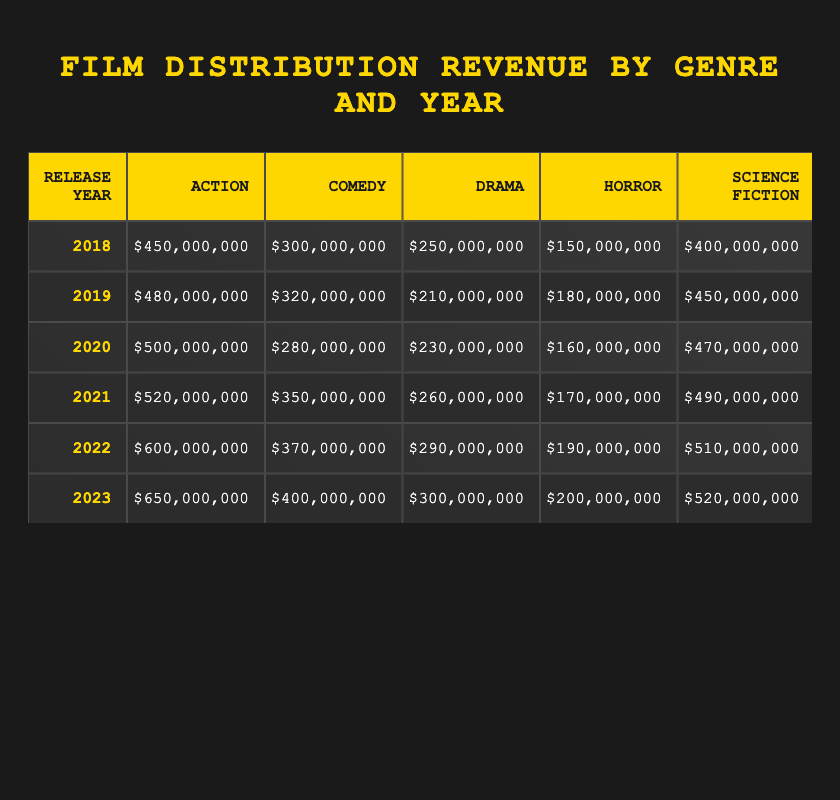What was the highest revenue for Action films, and in what year did it occur? The highest revenue for Action films is $650,000,000 in the year 2023, as this value is clearly indicated in the table.
Answer: 2023, $650,000,000 What is the average revenue for Animation films over the years 2018-2023? To find the average, add up the revenue for Animation films across the years: 200,000,000 + 220,000,000 + 210,000,000 + 240,000,000 + 250,000,000 + 270,000,000 = 1,480,000,000. Then divide by the number of years (6): 1,480,000,000 / 6 = 246,666,667.
Answer: 246,666,667 Did Horror films have a revenue higher than $200,000,000 in 2022? The revenue for Horror films in 2022 is $190,000,000, which is less than $200,000,000, so the statement is false.
Answer: No Which genre had the lowest total revenue in 2020? The total revenues for each genre in 2020 are: Action ($500,000,000), Comedy ($280,000,000), Drama ($230,000,000), Horror ($160,000,000), Science Fiction ($470,000,000), Animation ($210,000,000). The lowest is Horror at $160,000,000.
Answer: Horror What is the difference in revenue between the highest and lowest earning genres in 2021? The highest revenue in 2021 was for Action films at $520,000,000, and the lowest was for Horror films at $170,000,000. The difference is calculated as $520,000,000 - $170,000,000 = $350,000,000.
Answer: $350,000,000 In which year did Comedy films generate more than $350,000,000? According to the table, Comedy films generated over $350,000,000 in the years 2021 ($350,000,000), 2022 ($370,000,000), and 2023 ($400,000,000). The first year when the amount exceeded $350,000,000 is 2021, as it just matches in that year and exceeds in subsequent years.
Answer: 2021 What was the total revenue for Science Fiction films from 2018 to 2023? The revenues for Science Fiction films are: 400,000,000 (2018), 450,000,000 (2019), 470,000,000 (2020), 490,000,000 (2021), 510,000,000 (2022), and 520,000,000 (2023). Adding these values gives 400,000,000 + 450,000,000 + 470,000,000 + 490,000,000 + 510,000,000 + 520,000,000 = 2,840,000,000.
Answer: $2,840,000,000 Which genre showed the most consistent year-over-year increase in revenue from 2018 to 2023? Analyzing the rates of increase, Action films have increased from $450,000,000 in 2018 to $650,000,000 in 2023, showing an increase every year. On the contrary, other genres showed fluctuations. Therefore, Action films exhibit the most consistent growth.
Answer: Action For which years did Drama films have a revenue that was less than $250,000,000? The revenues for Drama films are as follows: 2018 ($250,000,000), 2019 ($210,000,000), 2020 ($230,000,000), 2021 ($260,000,000), 2022 ($290,000,000), and 2023 ($300,000,000). The years when the revenue was less than $250,000,000 are 2019 and 2020.
Answer: 2019, 2020 What was the total revenue of Action and Comedy films combined for the year 2022? The revenue for Action in 2022 is $600,000,000, and for Comedy, it is $370,000,000. The combined revenue is $600,000,000 + $370,000,000 = $970,000,000.
Answer: $970,000,000 